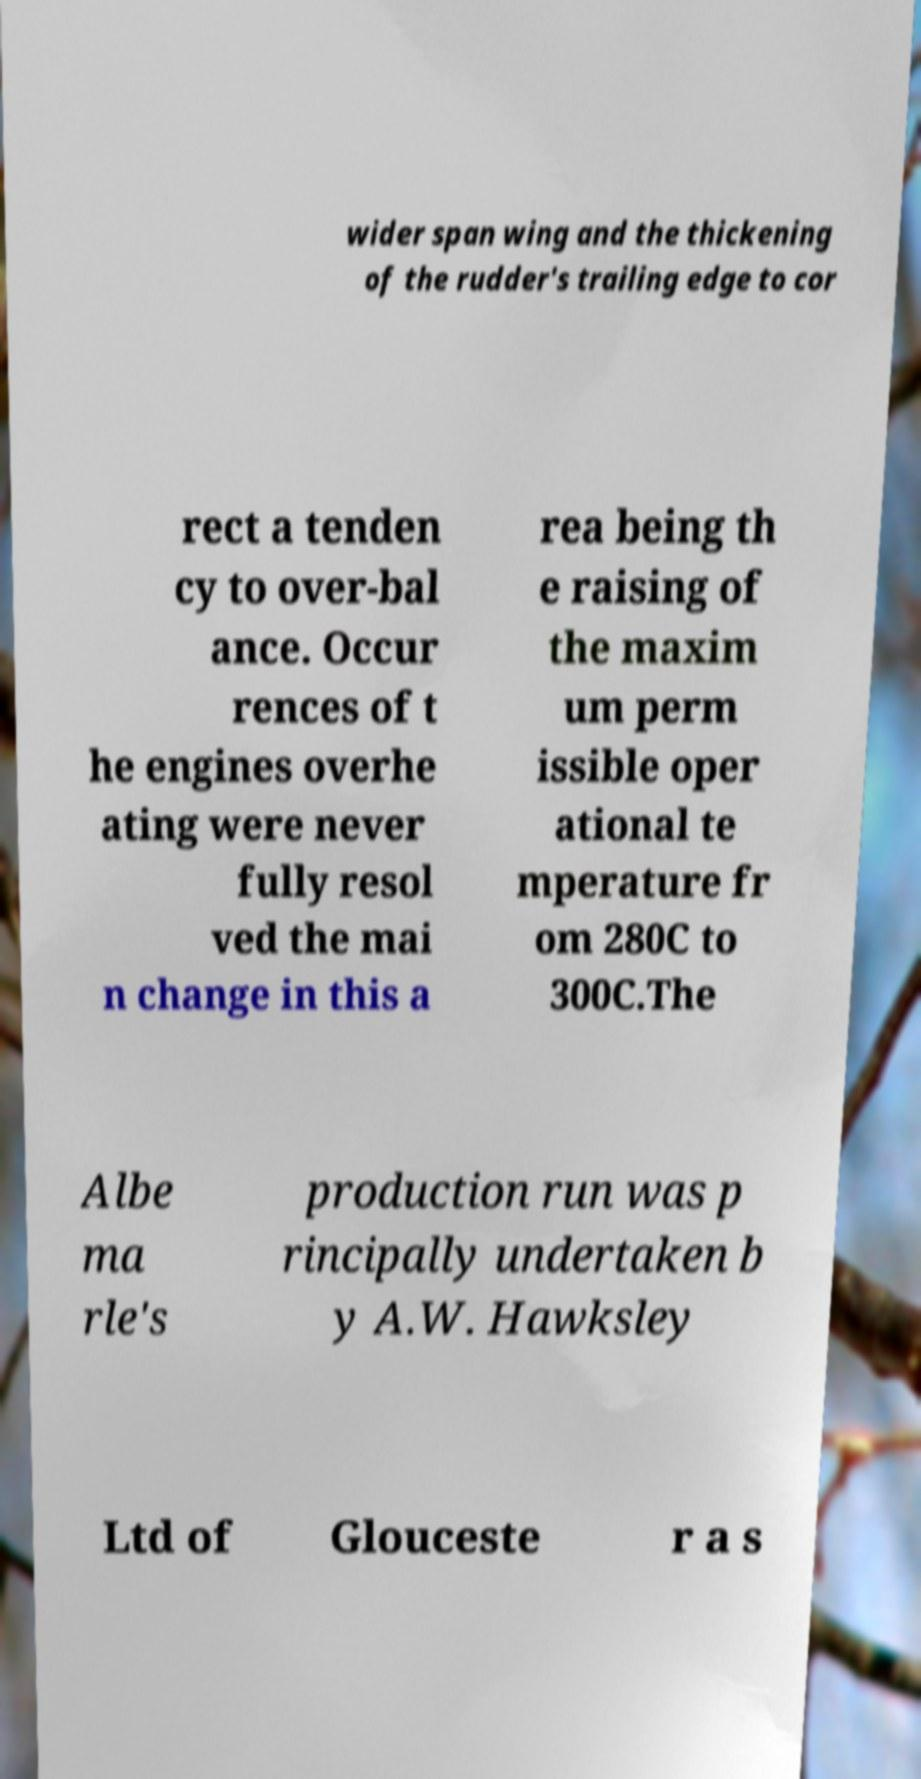Please read and relay the text visible in this image. What does it say? wider span wing and the thickening of the rudder's trailing edge to cor rect a tenden cy to over-bal ance. Occur rences of t he engines overhe ating were never fully resol ved the mai n change in this a rea being th e raising of the maxim um perm issible oper ational te mperature fr om 280C to 300C.The Albe ma rle's production run was p rincipally undertaken b y A.W. Hawksley Ltd of Glouceste r a s 